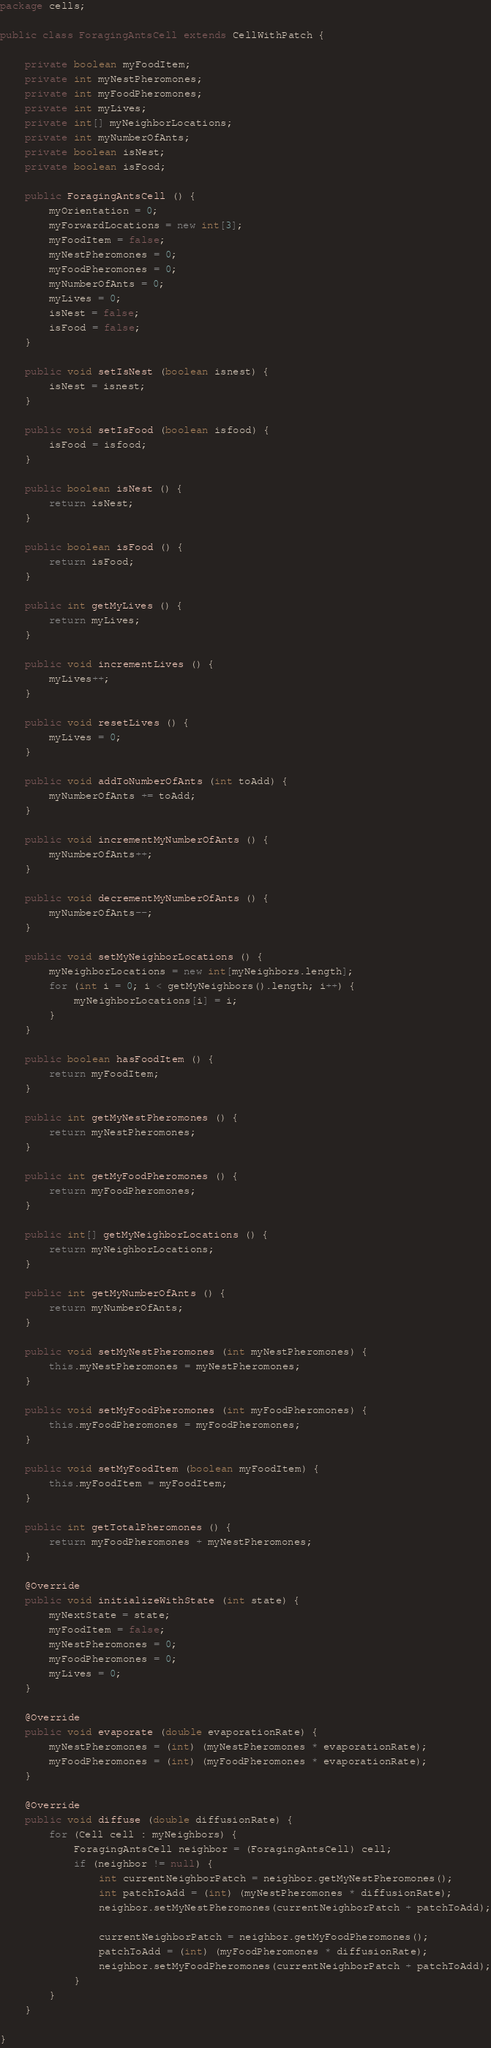Convert code to text. <code><loc_0><loc_0><loc_500><loc_500><_Java_>package cells;

public class ForagingAntsCell extends CellWithPatch {

    private boolean myFoodItem;
    private int myNestPheromones;
    private int myFoodPheromones;
    private int myLives;
    private int[] myNeighborLocations;
    private int myNumberOfAnts;
    private boolean isNest;
    private boolean isFood;

    public ForagingAntsCell () {
        myOrientation = 0;
        myForwardLocations = new int[3];
        myFoodItem = false;
        myNestPheromones = 0;
        myFoodPheromones = 0;
        myNumberOfAnts = 0;
        myLives = 0;
        isNest = false;
        isFood = false;
    }

    public void setIsNest (boolean isnest) {
        isNest = isnest;
    }

    public void setIsFood (boolean isfood) {
        isFood = isfood;
    }

    public boolean isNest () {
        return isNest;
    }

    public boolean isFood () {
        return isFood;
    }

    public int getMyLives () {
        return myLives;
    }

    public void incrementLives () {
        myLives++;
    }

    public void resetLives () {
        myLives = 0;
    }

    public void addToNumberOfAnts (int toAdd) {
        myNumberOfAnts += toAdd;
    }

    public void incrementMyNumberOfAnts () {
        myNumberOfAnts++;
    }

    public void decrementMyNumberOfAnts () {
        myNumberOfAnts--;
    }

    public void setMyNeighborLocations () {
        myNeighborLocations = new int[myNeighbors.length];
        for (int i = 0; i < getMyNeighbors().length; i++) {
            myNeighborLocations[i] = i;
        }
    }

    public boolean hasFoodItem () {
        return myFoodItem;
    }

    public int getMyNestPheromones () {
        return myNestPheromones;
    }

    public int getMyFoodPheromones () {
        return myFoodPheromones;
    }

    public int[] getMyNeighborLocations () {
        return myNeighborLocations;
    }

    public int getMyNumberOfAnts () {
        return myNumberOfAnts;
    }

    public void setMyNestPheromones (int myNestPheromones) {
        this.myNestPheromones = myNestPheromones;
    }

    public void setMyFoodPheromones (int myFoodPheromones) {
        this.myFoodPheromones = myFoodPheromones;
    }

    public void setMyFoodItem (boolean myFoodItem) {
        this.myFoodItem = myFoodItem;
    }

    public int getTotalPheromones () {
        return myFoodPheromones + myNestPheromones;
    }

    @Override
    public void initializeWithState (int state) {
        myNextState = state;
        myFoodItem = false;
        myNestPheromones = 0;
        myFoodPheromones = 0;
        myLives = 0;
    }

    @Override
    public void evaporate (double evaporationRate) {
        myNestPheromones = (int) (myNestPheromones * evaporationRate);
        myFoodPheromones = (int) (myFoodPheromones * evaporationRate);
    }

    @Override
    public void diffuse (double diffusionRate) {
        for (Cell cell : myNeighbors) {
            ForagingAntsCell neighbor = (ForagingAntsCell) cell;
            if (neighbor != null) {
                int currentNeighborPatch = neighbor.getMyNestPheromones();
                int patchToAdd = (int) (myNestPheromones * diffusionRate);
                neighbor.setMyNestPheromones(currentNeighborPatch + patchToAdd);

                currentNeighborPatch = neighbor.getMyFoodPheromones();
                patchToAdd = (int) (myFoodPheromones * diffusionRate);
                neighbor.setMyFoodPheromones(currentNeighborPatch + patchToAdd);
            }
        }
    }

}
</code> 